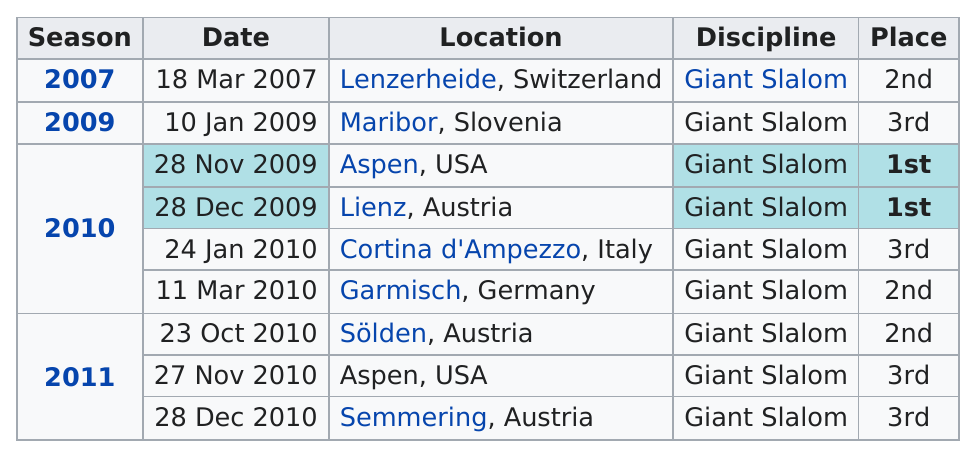Mention a couple of crucial points in this snapshot. The finishing place of the last race in December 2010 was third. The location of a first-place finish was not limited to Aspen, USA, as Lienz, Austria also hosted a first-place finish. The speaker is informing the audience that the person in question won their first competition in Aspen, USA. The final race's finishing place was not first, but rather third. This racer has achieved three second place finishes. 